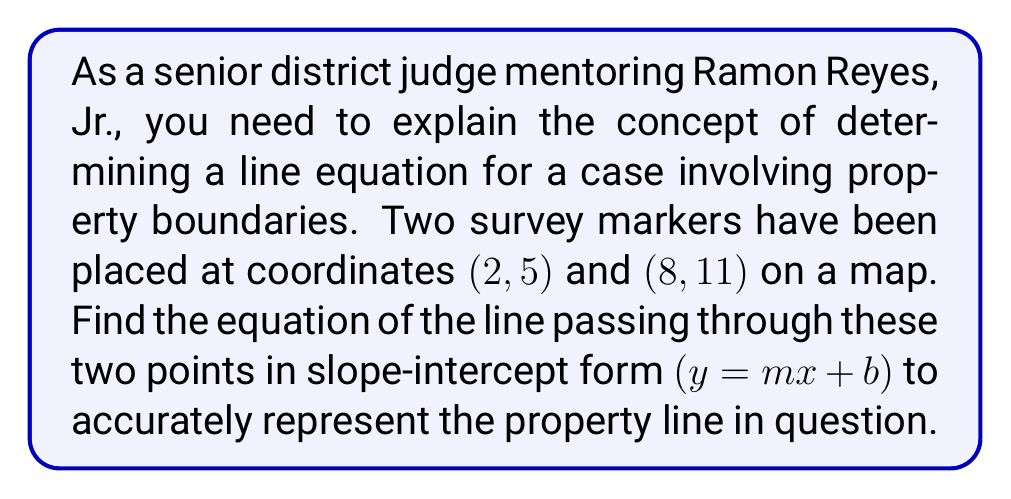Teach me how to tackle this problem. To find the equation of the line passing through two points in slope-intercept form $(y = mx + b)$, we'll follow these steps:

1. Calculate the slope $(m)$ using the slope formula:
   $$m = \frac{y_2 - y_1}{x_2 - x_1}$$
   
   Where $(x_1, y_1)$ is the first point and $(x_2, y_2)$ is the second point.

2. Substitute the slope and one of the points into the point-slope form equation:
   $$y - y_1 = m(x - x_1)$$

3. Rearrange the equation to slope-intercept form $(y = mx + b)$.

Step 1: Calculate the slope
$$(x_1, y_1) = (2, 5)$$
$$(x_2, y_2) = (8, 11)$$

$$m = \frac{y_2 - y_1}{x_2 - x_1} = \frac{11 - 5}{8 - 2} = \frac{6}{6} = 1$$

Step 2: Use point-slope form with $(x_1, y_1) = (2, 5)$
$$y - 5 = 1(x - 2)$$

Step 3: Rearrange to slope-intercept form
$$\begin{align}
y - 5 &= x - 2 \\
y &= x - 2 + 5 \\
y &= x + 3
\end{align}$$

Therefore, the equation of the line in slope-intercept form is $y = x + 3$.
Answer: $y = x + 3$ 